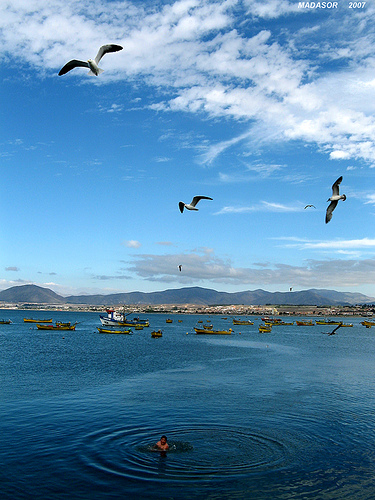Are there any birds or other wildlife visible? Certainly. Three birds, likely seagulls, are in flight, adding dynamism to the scene. Their presence hints at the rich marine life that undoubtedly thrives below the surface, as birds often flock to areas abundant in fish, which might also interest the local fishermen. 